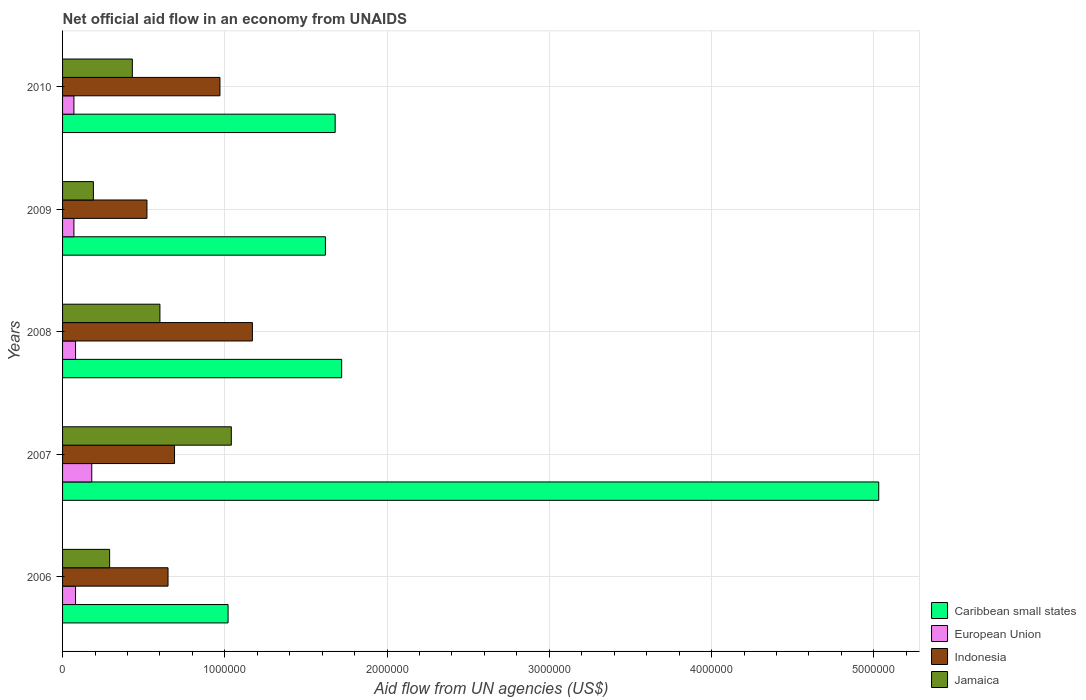How many different coloured bars are there?
Ensure brevity in your answer.  4. Are the number of bars on each tick of the Y-axis equal?
Provide a short and direct response. Yes. What is the label of the 2nd group of bars from the top?
Your response must be concise. 2009. In how many cases, is the number of bars for a given year not equal to the number of legend labels?
Your answer should be compact. 0. Across all years, what is the maximum net official aid flow in European Union?
Keep it short and to the point. 1.80e+05. Across all years, what is the minimum net official aid flow in European Union?
Keep it short and to the point. 7.00e+04. What is the total net official aid flow in Jamaica in the graph?
Keep it short and to the point. 2.55e+06. What is the difference between the net official aid flow in Indonesia in 2006 and that in 2010?
Your response must be concise. -3.20e+05. What is the difference between the net official aid flow in Indonesia in 2009 and the net official aid flow in Jamaica in 2008?
Provide a succinct answer. -8.00e+04. What is the average net official aid flow in European Union per year?
Offer a very short reply. 9.60e+04. In the year 2010, what is the difference between the net official aid flow in Jamaica and net official aid flow in Caribbean small states?
Make the answer very short. -1.25e+06. Is the net official aid flow in Indonesia in 2006 less than that in 2008?
Provide a succinct answer. Yes. What is the difference between the highest and the second highest net official aid flow in Jamaica?
Keep it short and to the point. 4.40e+05. Is the sum of the net official aid flow in Indonesia in 2007 and 2009 greater than the maximum net official aid flow in Jamaica across all years?
Provide a short and direct response. Yes. Is it the case that in every year, the sum of the net official aid flow in Indonesia and net official aid flow in Caribbean small states is greater than the sum of net official aid flow in European Union and net official aid flow in Jamaica?
Provide a short and direct response. No. What does the 4th bar from the top in 2010 represents?
Make the answer very short. Caribbean small states. What does the 3rd bar from the bottom in 2007 represents?
Offer a terse response. Indonesia. How many bars are there?
Your response must be concise. 20. How many years are there in the graph?
Your answer should be compact. 5. Are the values on the major ticks of X-axis written in scientific E-notation?
Give a very brief answer. No. Does the graph contain any zero values?
Your answer should be compact. No. How many legend labels are there?
Keep it short and to the point. 4. What is the title of the graph?
Offer a very short reply. Net official aid flow in an economy from UNAIDS. Does "Sierra Leone" appear as one of the legend labels in the graph?
Provide a succinct answer. No. What is the label or title of the X-axis?
Offer a terse response. Aid flow from UN agencies (US$). What is the label or title of the Y-axis?
Your response must be concise. Years. What is the Aid flow from UN agencies (US$) of Caribbean small states in 2006?
Your response must be concise. 1.02e+06. What is the Aid flow from UN agencies (US$) of European Union in 2006?
Your answer should be very brief. 8.00e+04. What is the Aid flow from UN agencies (US$) of Indonesia in 2006?
Your response must be concise. 6.50e+05. What is the Aid flow from UN agencies (US$) in Caribbean small states in 2007?
Make the answer very short. 5.03e+06. What is the Aid flow from UN agencies (US$) of European Union in 2007?
Keep it short and to the point. 1.80e+05. What is the Aid flow from UN agencies (US$) of Indonesia in 2007?
Your answer should be compact. 6.90e+05. What is the Aid flow from UN agencies (US$) in Jamaica in 2007?
Your answer should be very brief. 1.04e+06. What is the Aid flow from UN agencies (US$) in Caribbean small states in 2008?
Your response must be concise. 1.72e+06. What is the Aid flow from UN agencies (US$) of Indonesia in 2008?
Offer a terse response. 1.17e+06. What is the Aid flow from UN agencies (US$) of Jamaica in 2008?
Ensure brevity in your answer.  6.00e+05. What is the Aid flow from UN agencies (US$) of Caribbean small states in 2009?
Your response must be concise. 1.62e+06. What is the Aid flow from UN agencies (US$) in Indonesia in 2009?
Provide a succinct answer. 5.20e+05. What is the Aid flow from UN agencies (US$) in Caribbean small states in 2010?
Ensure brevity in your answer.  1.68e+06. What is the Aid flow from UN agencies (US$) of European Union in 2010?
Ensure brevity in your answer.  7.00e+04. What is the Aid flow from UN agencies (US$) in Indonesia in 2010?
Ensure brevity in your answer.  9.70e+05. Across all years, what is the maximum Aid flow from UN agencies (US$) in Caribbean small states?
Ensure brevity in your answer.  5.03e+06. Across all years, what is the maximum Aid flow from UN agencies (US$) of Indonesia?
Give a very brief answer. 1.17e+06. Across all years, what is the maximum Aid flow from UN agencies (US$) of Jamaica?
Ensure brevity in your answer.  1.04e+06. Across all years, what is the minimum Aid flow from UN agencies (US$) in Caribbean small states?
Offer a terse response. 1.02e+06. Across all years, what is the minimum Aid flow from UN agencies (US$) in Indonesia?
Keep it short and to the point. 5.20e+05. What is the total Aid flow from UN agencies (US$) of Caribbean small states in the graph?
Offer a very short reply. 1.11e+07. What is the total Aid flow from UN agencies (US$) in European Union in the graph?
Your answer should be compact. 4.80e+05. What is the total Aid flow from UN agencies (US$) of Jamaica in the graph?
Provide a succinct answer. 2.55e+06. What is the difference between the Aid flow from UN agencies (US$) in Caribbean small states in 2006 and that in 2007?
Ensure brevity in your answer.  -4.01e+06. What is the difference between the Aid flow from UN agencies (US$) of Indonesia in 2006 and that in 2007?
Your answer should be very brief. -4.00e+04. What is the difference between the Aid flow from UN agencies (US$) of Jamaica in 2006 and that in 2007?
Make the answer very short. -7.50e+05. What is the difference between the Aid flow from UN agencies (US$) of Caribbean small states in 2006 and that in 2008?
Give a very brief answer. -7.00e+05. What is the difference between the Aid flow from UN agencies (US$) of Indonesia in 2006 and that in 2008?
Provide a short and direct response. -5.20e+05. What is the difference between the Aid flow from UN agencies (US$) in Jamaica in 2006 and that in 2008?
Keep it short and to the point. -3.10e+05. What is the difference between the Aid flow from UN agencies (US$) of Caribbean small states in 2006 and that in 2009?
Your answer should be very brief. -6.00e+05. What is the difference between the Aid flow from UN agencies (US$) in European Union in 2006 and that in 2009?
Give a very brief answer. 10000. What is the difference between the Aid flow from UN agencies (US$) of Caribbean small states in 2006 and that in 2010?
Your response must be concise. -6.60e+05. What is the difference between the Aid flow from UN agencies (US$) in Indonesia in 2006 and that in 2010?
Provide a short and direct response. -3.20e+05. What is the difference between the Aid flow from UN agencies (US$) in Jamaica in 2006 and that in 2010?
Provide a short and direct response. -1.40e+05. What is the difference between the Aid flow from UN agencies (US$) in Caribbean small states in 2007 and that in 2008?
Provide a succinct answer. 3.31e+06. What is the difference between the Aid flow from UN agencies (US$) in Indonesia in 2007 and that in 2008?
Offer a terse response. -4.80e+05. What is the difference between the Aid flow from UN agencies (US$) in Caribbean small states in 2007 and that in 2009?
Keep it short and to the point. 3.41e+06. What is the difference between the Aid flow from UN agencies (US$) in Indonesia in 2007 and that in 2009?
Give a very brief answer. 1.70e+05. What is the difference between the Aid flow from UN agencies (US$) of Jamaica in 2007 and that in 2009?
Your answer should be compact. 8.50e+05. What is the difference between the Aid flow from UN agencies (US$) of Caribbean small states in 2007 and that in 2010?
Give a very brief answer. 3.35e+06. What is the difference between the Aid flow from UN agencies (US$) in Indonesia in 2007 and that in 2010?
Your answer should be very brief. -2.80e+05. What is the difference between the Aid flow from UN agencies (US$) in Jamaica in 2007 and that in 2010?
Offer a very short reply. 6.10e+05. What is the difference between the Aid flow from UN agencies (US$) of Caribbean small states in 2008 and that in 2009?
Your response must be concise. 1.00e+05. What is the difference between the Aid flow from UN agencies (US$) of Indonesia in 2008 and that in 2009?
Your answer should be compact. 6.50e+05. What is the difference between the Aid flow from UN agencies (US$) of Jamaica in 2008 and that in 2009?
Offer a terse response. 4.10e+05. What is the difference between the Aid flow from UN agencies (US$) of Caribbean small states in 2008 and that in 2010?
Your response must be concise. 4.00e+04. What is the difference between the Aid flow from UN agencies (US$) in European Union in 2008 and that in 2010?
Offer a terse response. 10000. What is the difference between the Aid flow from UN agencies (US$) in Indonesia in 2008 and that in 2010?
Make the answer very short. 2.00e+05. What is the difference between the Aid flow from UN agencies (US$) in Caribbean small states in 2009 and that in 2010?
Offer a very short reply. -6.00e+04. What is the difference between the Aid flow from UN agencies (US$) in European Union in 2009 and that in 2010?
Your answer should be compact. 0. What is the difference between the Aid flow from UN agencies (US$) in Indonesia in 2009 and that in 2010?
Ensure brevity in your answer.  -4.50e+05. What is the difference between the Aid flow from UN agencies (US$) of Caribbean small states in 2006 and the Aid flow from UN agencies (US$) of European Union in 2007?
Your answer should be compact. 8.40e+05. What is the difference between the Aid flow from UN agencies (US$) in Caribbean small states in 2006 and the Aid flow from UN agencies (US$) in Jamaica in 2007?
Your answer should be very brief. -2.00e+04. What is the difference between the Aid flow from UN agencies (US$) in European Union in 2006 and the Aid flow from UN agencies (US$) in Indonesia in 2007?
Keep it short and to the point. -6.10e+05. What is the difference between the Aid flow from UN agencies (US$) in European Union in 2006 and the Aid flow from UN agencies (US$) in Jamaica in 2007?
Your answer should be very brief. -9.60e+05. What is the difference between the Aid flow from UN agencies (US$) in Indonesia in 2006 and the Aid flow from UN agencies (US$) in Jamaica in 2007?
Provide a short and direct response. -3.90e+05. What is the difference between the Aid flow from UN agencies (US$) of Caribbean small states in 2006 and the Aid flow from UN agencies (US$) of European Union in 2008?
Your answer should be compact. 9.40e+05. What is the difference between the Aid flow from UN agencies (US$) of European Union in 2006 and the Aid flow from UN agencies (US$) of Indonesia in 2008?
Your answer should be compact. -1.09e+06. What is the difference between the Aid flow from UN agencies (US$) in European Union in 2006 and the Aid flow from UN agencies (US$) in Jamaica in 2008?
Your response must be concise. -5.20e+05. What is the difference between the Aid flow from UN agencies (US$) in Caribbean small states in 2006 and the Aid flow from UN agencies (US$) in European Union in 2009?
Provide a short and direct response. 9.50e+05. What is the difference between the Aid flow from UN agencies (US$) in Caribbean small states in 2006 and the Aid flow from UN agencies (US$) in Indonesia in 2009?
Your response must be concise. 5.00e+05. What is the difference between the Aid flow from UN agencies (US$) in Caribbean small states in 2006 and the Aid flow from UN agencies (US$) in Jamaica in 2009?
Make the answer very short. 8.30e+05. What is the difference between the Aid flow from UN agencies (US$) of European Union in 2006 and the Aid flow from UN agencies (US$) of Indonesia in 2009?
Keep it short and to the point. -4.40e+05. What is the difference between the Aid flow from UN agencies (US$) in Indonesia in 2006 and the Aid flow from UN agencies (US$) in Jamaica in 2009?
Keep it short and to the point. 4.60e+05. What is the difference between the Aid flow from UN agencies (US$) of Caribbean small states in 2006 and the Aid flow from UN agencies (US$) of European Union in 2010?
Make the answer very short. 9.50e+05. What is the difference between the Aid flow from UN agencies (US$) in Caribbean small states in 2006 and the Aid flow from UN agencies (US$) in Jamaica in 2010?
Your answer should be compact. 5.90e+05. What is the difference between the Aid flow from UN agencies (US$) of European Union in 2006 and the Aid flow from UN agencies (US$) of Indonesia in 2010?
Make the answer very short. -8.90e+05. What is the difference between the Aid flow from UN agencies (US$) in European Union in 2006 and the Aid flow from UN agencies (US$) in Jamaica in 2010?
Your answer should be compact. -3.50e+05. What is the difference between the Aid flow from UN agencies (US$) of Caribbean small states in 2007 and the Aid flow from UN agencies (US$) of European Union in 2008?
Give a very brief answer. 4.95e+06. What is the difference between the Aid flow from UN agencies (US$) in Caribbean small states in 2007 and the Aid flow from UN agencies (US$) in Indonesia in 2008?
Your answer should be compact. 3.86e+06. What is the difference between the Aid flow from UN agencies (US$) in Caribbean small states in 2007 and the Aid flow from UN agencies (US$) in Jamaica in 2008?
Provide a succinct answer. 4.43e+06. What is the difference between the Aid flow from UN agencies (US$) of European Union in 2007 and the Aid flow from UN agencies (US$) of Indonesia in 2008?
Offer a very short reply. -9.90e+05. What is the difference between the Aid flow from UN agencies (US$) of European Union in 2007 and the Aid flow from UN agencies (US$) of Jamaica in 2008?
Provide a short and direct response. -4.20e+05. What is the difference between the Aid flow from UN agencies (US$) of Indonesia in 2007 and the Aid flow from UN agencies (US$) of Jamaica in 2008?
Offer a very short reply. 9.00e+04. What is the difference between the Aid flow from UN agencies (US$) in Caribbean small states in 2007 and the Aid flow from UN agencies (US$) in European Union in 2009?
Your response must be concise. 4.96e+06. What is the difference between the Aid flow from UN agencies (US$) in Caribbean small states in 2007 and the Aid flow from UN agencies (US$) in Indonesia in 2009?
Your answer should be very brief. 4.51e+06. What is the difference between the Aid flow from UN agencies (US$) of Caribbean small states in 2007 and the Aid flow from UN agencies (US$) of Jamaica in 2009?
Your answer should be compact. 4.84e+06. What is the difference between the Aid flow from UN agencies (US$) of European Union in 2007 and the Aid flow from UN agencies (US$) of Indonesia in 2009?
Provide a succinct answer. -3.40e+05. What is the difference between the Aid flow from UN agencies (US$) of European Union in 2007 and the Aid flow from UN agencies (US$) of Jamaica in 2009?
Your response must be concise. -10000. What is the difference between the Aid flow from UN agencies (US$) of Caribbean small states in 2007 and the Aid flow from UN agencies (US$) of European Union in 2010?
Ensure brevity in your answer.  4.96e+06. What is the difference between the Aid flow from UN agencies (US$) of Caribbean small states in 2007 and the Aid flow from UN agencies (US$) of Indonesia in 2010?
Your answer should be compact. 4.06e+06. What is the difference between the Aid flow from UN agencies (US$) of Caribbean small states in 2007 and the Aid flow from UN agencies (US$) of Jamaica in 2010?
Give a very brief answer. 4.60e+06. What is the difference between the Aid flow from UN agencies (US$) in European Union in 2007 and the Aid flow from UN agencies (US$) in Indonesia in 2010?
Make the answer very short. -7.90e+05. What is the difference between the Aid flow from UN agencies (US$) in Indonesia in 2007 and the Aid flow from UN agencies (US$) in Jamaica in 2010?
Offer a terse response. 2.60e+05. What is the difference between the Aid flow from UN agencies (US$) of Caribbean small states in 2008 and the Aid flow from UN agencies (US$) of European Union in 2009?
Give a very brief answer. 1.65e+06. What is the difference between the Aid flow from UN agencies (US$) of Caribbean small states in 2008 and the Aid flow from UN agencies (US$) of Indonesia in 2009?
Keep it short and to the point. 1.20e+06. What is the difference between the Aid flow from UN agencies (US$) in Caribbean small states in 2008 and the Aid flow from UN agencies (US$) in Jamaica in 2009?
Your response must be concise. 1.53e+06. What is the difference between the Aid flow from UN agencies (US$) in European Union in 2008 and the Aid flow from UN agencies (US$) in Indonesia in 2009?
Offer a very short reply. -4.40e+05. What is the difference between the Aid flow from UN agencies (US$) of European Union in 2008 and the Aid flow from UN agencies (US$) of Jamaica in 2009?
Your answer should be very brief. -1.10e+05. What is the difference between the Aid flow from UN agencies (US$) in Indonesia in 2008 and the Aid flow from UN agencies (US$) in Jamaica in 2009?
Give a very brief answer. 9.80e+05. What is the difference between the Aid flow from UN agencies (US$) of Caribbean small states in 2008 and the Aid flow from UN agencies (US$) of European Union in 2010?
Your answer should be very brief. 1.65e+06. What is the difference between the Aid flow from UN agencies (US$) in Caribbean small states in 2008 and the Aid flow from UN agencies (US$) in Indonesia in 2010?
Give a very brief answer. 7.50e+05. What is the difference between the Aid flow from UN agencies (US$) of Caribbean small states in 2008 and the Aid flow from UN agencies (US$) of Jamaica in 2010?
Ensure brevity in your answer.  1.29e+06. What is the difference between the Aid flow from UN agencies (US$) in European Union in 2008 and the Aid flow from UN agencies (US$) in Indonesia in 2010?
Your answer should be very brief. -8.90e+05. What is the difference between the Aid flow from UN agencies (US$) in European Union in 2008 and the Aid flow from UN agencies (US$) in Jamaica in 2010?
Make the answer very short. -3.50e+05. What is the difference between the Aid flow from UN agencies (US$) of Indonesia in 2008 and the Aid flow from UN agencies (US$) of Jamaica in 2010?
Ensure brevity in your answer.  7.40e+05. What is the difference between the Aid flow from UN agencies (US$) of Caribbean small states in 2009 and the Aid flow from UN agencies (US$) of European Union in 2010?
Provide a succinct answer. 1.55e+06. What is the difference between the Aid flow from UN agencies (US$) in Caribbean small states in 2009 and the Aid flow from UN agencies (US$) in Indonesia in 2010?
Keep it short and to the point. 6.50e+05. What is the difference between the Aid flow from UN agencies (US$) of Caribbean small states in 2009 and the Aid flow from UN agencies (US$) of Jamaica in 2010?
Give a very brief answer. 1.19e+06. What is the difference between the Aid flow from UN agencies (US$) of European Union in 2009 and the Aid flow from UN agencies (US$) of Indonesia in 2010?
Give a very brief answer. -9.00e+05. What is the difference between the Aid flow from UN agencies (US$) in European Union in 2009 and the Aid flow from UN agencies (US$) in Jamaica in 2010?
Your answer should be very brief. -3.60e+05. What is the average Aid flow from UN agencies (US$) of Caribbean small states per year?
Provide a short and direct response. 2.21e+06. What is the average Aid flow from UN agencies (US$) in European Union per year?
Ensure brevity in your answer.  9.60e+04. What is the average Aid flow from UN agencies (US$) in Indonesia per year?
Provide a short and direct response. 8.00e+05. What is the average Aid flow from UN agencies (US$) of Jamaica per year?
Keep it short and to the point. 5.10e+05. In the year 2006, what is the difference between the Aid flow from UN agencies (US$) in Caribbean small states and Aid flow from UN agencies (US$) in European Union?
Provide a short and direct response. 9.40e+05. In the year 2006, what is the difference between the Aid flow from UN agencies (US$) in Caribbean small states and Aid flow from UN agencies (US$) in Jamaica?
Keep it short and to the point. 7.30e+05. In the year 2006, what is the difference between the Aid flow from UN agencies (US$) of European Union and Aid flow from UN agencies (US$) of Indonesia?
Provide a short and direct response. -5.70e+05. In the year 2006, what is the difference between the Aid flow from UN agencies (US$) in European Union and Aid flow from UN agencies (US$) in Jamaica?
Offer a very short reply. -2.10e+05. In the year 2006, what is the difference between the Aid flow from UN agencies (US$) in Indonesia and Aid flow from UN agencies (US$) in Jamaica?
Your response must be concise. 3.60e+05. In the year 2007, what is the difference between the Aid flow from UN agencies (US$) of Caribbean small states and Aid flow from UN agencies (US$) of European Union?
Offer a terse response. 4.85e+06. In the year 2007, what is the difference between the Aid flow from UN agencies (US$) of Caribbean small states and Aid flow from UN agencies (US$) of Indonesia?
Your answer should be very brief. 4.34e+06. In the year 2007, what is the difference between the Aid flow from UN agencies (US$) of Caribbean small states and Aid flow from UN agencies (US$) of Jamaica?
Your response must be concise. 3.99e+06. In the year 2007, what is the difference between the Aid flow from UN agencies (US$) in European Union and Aid flow from UN agencies (US$) in Indonesia?
Your answer should be very brief. -5.10e+05. In the year 2007, what is the difference between the Aid flow from UN agencies (US$) of European Union and Aid flow from UN agencies (US$) of Jamaica?
Give a very brief answer. -8.60e+05. In the year 2007, what is the difference between the Aid flow from UN agencies (US$) in Indonesia and Aid flow from UN agencies (US$) in Jamaica?
Keep it short and to the point. -3.50e+05. In the year 2008, what is the difference between the Aid flow from UN agencies (US$) of Caribbean small states and Aid flow from UN agencies (US$) of European Union?
Offer a terse response. 1.64e+06. In the year 2008, what is the difference between the Aid flow from UN agencies (US$) of Caribbean small states and Aid flow from UN agencies (US$) of Jamaica?
Offer a terse response. 1.12e+06. In the year 2008, what is the difference between the Aid flow from UN agencies (US$) of European Union and Aid flow from UN agencies (US$) of Indonesia?
Provide a succinct answer. -1.09e+06. In the year 2008, what is the difference between the Aid flow from UN agencies (US$) of European Union and Aid flow from UN agencies (US$) of Jamaica?
Provide a short and direct response. -5.20e+05. In the year 2008, what is the difference between the Aid flow from UN agencies (US$) of Indonesia and Aid flow from UN agencies (US$) of Jamaica?
Your answer should be compact. 5.70e+05. In the year 2009, what is the difference between the Aid flow from UN agencies (US$) of Caribbean small states and Aid flow from UN agencies (US$) of European Union?
Your response must be concise. 1.55e+06. In the year 2009, what is the difference between the Aid flow from UN agencies (US$) of Caribbean small states and Aid flow from UN agencies (US$) of Indonesia?
Keep it short and to the point. 1.10e+06. In the year 2009, what is the difference between the Aid flow from UN agencies (US$) of Caribbean small states and Aid flow from UN agencies (US$) of Jamaica?
Your answer should be very brief. 1.43e+06. In the year 2009, what is the difference between the Aid flow from UN agencies (US$) in European Union and Aid flow from UN agencies (US$) in Indonesia?
Ensure brevity in your answer.  -4.50e+05. In the year 2010, what is the difference between the Aid flow from UN agencies (US$) of Caribbean small states and Aid flow from UN agencies (US$) of European Union?
Offer a very short reply. 1.61e+06. In the year 2010, what is the difference between the Aid flow from UN agencies (US$) of Caribbean small states and Aid flow from UN agencies (US$) of Indonesia?
Keep it short and to the point. 7.10e+05. In the year 2010, what is the difference between the Aid flow from UN agencies (US$) of Caribbean small states and Aid flow from UN agencies (US$) of Jamaica?
Make the answer very short. 1.25e+06. In the year 2010, what is the difference between the Aid flow from UN agencies (US$) of European Union and Aid flow from UN agencies (US$) of Indonesia?
Your answer should be very brief. -9.00e+05. In the year 2010, what is the difference between the Aid flow from UN agencies (US$) in European Union and Aid flow from UN agencies (US$) in Jamaica?
Offer a terse response. -3.60e+05. In the year 2010, what is the difference between the Aid flow from UN agencies (US$) of Indonesia and Aid flow from UN agencies (US$) of Jamaica?
Your answer should be compact. 5.40e+05. What is the ratio of the Aid flow from UN agencies (US$) of Caribbean small states in 2006 to that in 2007?
Provide a short and direct response. 0.2. What is the ratio of the Aid flow from UN agencies (US$) in European Union in 2006 to that in 2007?
Offer a terse response. 0.44. What is the ratio of the Aid flow from UN agencies (US$) in Indonesia in 2006 to that in 2007?
Give a very brief answer. 0.94. What is the ratio of the Aid flow from UN agencies (US$) in Jamaica in 2006 to that in 2007?
Provide a short and direct response. 0.28. What is the ratio of the Aid flow from UN agencies (US$) of Caribbean small states in 2006 to that in 2008?
Offer a terse response. 0.59. What is the ratio of the Aid flow from UN agencies (US$) in Indonesia in 2006 to that in 2008?
Ensure brevity in your answer.  0.56. What is the ratio of the Aid flow from UN agencies (US$) in Jamaica in 2006 to that in 2008?
Give a very brief answer. 0.48. What is the ratio of the Aid flow from UN agencies (US$) of Caribbean small states in 2006 to that in 2009?
Offer a terse response. 0.63. What is the ratio of the Aid flow from UN agencies (US$) of Indonesia in 2006 to that in 2009?
Provide a short and direct response. 1.25. What is the ratio of the Aid flow from UN agencies (US$) of Jamaica in 2006 to that in 2009?
Your response must be concise. 1.53. What is the ratio of the Aid flow from UN agencies (US$) of Caribbean small states in 2006 to that in 2010?
Ensure brevity in your answer.  0.61. What is the ratio of the Aid flow from UN agencies (US$) of European Union in 2006 to that in 2010?
Provide a succinct answer. 1.14. What is the ratio of the Aid flow from UN agencies (US$) of Indonesia in 2006 to that in 2010?
Make the answer very short. 0.67. What is the ratio of the Aid flow from UN agencies (US$) of Jamaica in 2006 to that in 2010?
Your answer should be very brief. 0.67. What is the ratio of the Aid flow from UN agencies (US$) in Caribbean small states in 2007 to that in 2008?
Your answer should be very brief. 2.92. What is the ratio of the Aid flow from UN agencies (US$) in European Union in 2007 to that in 2008?
Provide a succinct answer. 2.25. What is the ratio of the Aid flow from UN agencies (US$) of Indonesia in 2007 to that in 2008?
Provide a succinct answer. 0.59. What is the ratio of the Aid flow from UN agencies (US$) of Jamaica in 2007 to that in 2008?
Give a very brief answer. 1.73. What is the ratio of the Aid flow from UN agencies (US$) of Caribbean small states in 2007 to that in 2009?
Provide a succinct answer. 3.1. What is the ratio of the Aid flow from UN agencies (US$) in European Union in 2007 to that in 2009?
Your answer should be compact. 2.57. What is the ratio of the Aid flow from UN agencies (US$) of Indonesia in 2007 to that in 2009?
Keep it short and to the point. 1.33. What is the ratio of the Aid flow from UN agencies (US$) of Jamaica in 2007 to that in 2009?
Your answer should be compact. 5.47. What is the ratio of the Aid flow from UN agencies (US$) of Caribbean small states in 2007 to that in 2010?
Make the answer very short. 2.99. What is the ratio of the Aid flow from UN agencies (US$) in European Union in 2007 to that in 2010?
Your answer should be compact. 2.57. What is the ratio of the Aid flow from UN agencies (US$) of Indonesia in 2007 to that in 2010?
Keep it short and to the point. 0.71. What is the ratio of the Aid flow from UN agencies (US$) in Jamaica in 2007 to that in 2010?
Offer a very short reply. 2.42. What is the ratio of the Aid flow from UN agencies (US$) of Caribbean small states in 2008 to that in 2009?
Ensure brevity in your answer.  1.06. What is the ratio of the Aid flow from UN agencies (US$) of Indonesia in 2008 to that in 2009?
Offer a terse response. 2.25. What is the ratio of the Aid flow from UN agencies (US$) of Jamaica in 2008 to that in 2009?
Keep it short and to the point. 3.16. What is the ratio of the Aid flow from UN agencies (US$) of Caribbean small states in 2008 to that in 2010?
Make the answer very short. 1.02. What is the ratio of the Aid flow from UN agencies (US$) of European Union in 2008 to that in 2010?
Make the answer very short. 1.14. What is the ratio of the Aid flow from UN agencies (US$) in Indonesia in 2008 to that in 2010?
Your answer should be compact. 1.21. What is the ratio of the Aid flow from UN agencies (US$) of Jamaica in 2008 to that in 2010?
Provide a short and direct response. 1.4. What is the ratio of the Aid flow from UN agencies (US$) in Caribbean small states in 2009 to that in 2010?
Offer a very short reply. 0.96. What is the ratio of the Aid flow from UN agencies (US$) of European Union in 2009 to that in 2010?
Ensure brevity in your answer.  1. What is the ratio of the Aid flow from UN agencies (US$) of Indonesia in 2009 to that in 2010?
Your answer should be compact. 0.54. What is the ratio of the Aid flow from UN agencies (US$) of Jamaica in 2009 to that in 2010?
Give a very brief answer. 0.44. What is the difference between the highest and the second highest Aid flow from UN agencies (US$) in Caribbean small states?
Your response must be concise. 3.31e+06. What is the difference between the highest and the second highest Aid flow from UN agencies (US$) of Indonesia?
Give a very brief answer. 2.00e+05. What is the difference between the highest and the lowest Aid flow from UN agencies (US$) of Caribbean small states?
Provide a short and direct response. 4.01e+06. What is the difference between the highest and the lowest Aid flow from UN agencies (US$) in Indonesia?
Offer a very short reply. 6.50e+05. What is the difference between the highest and the lowest Aid flow from UN agencies (US$) in Jamaica?
Make the answer very short. 8.50e+05. 